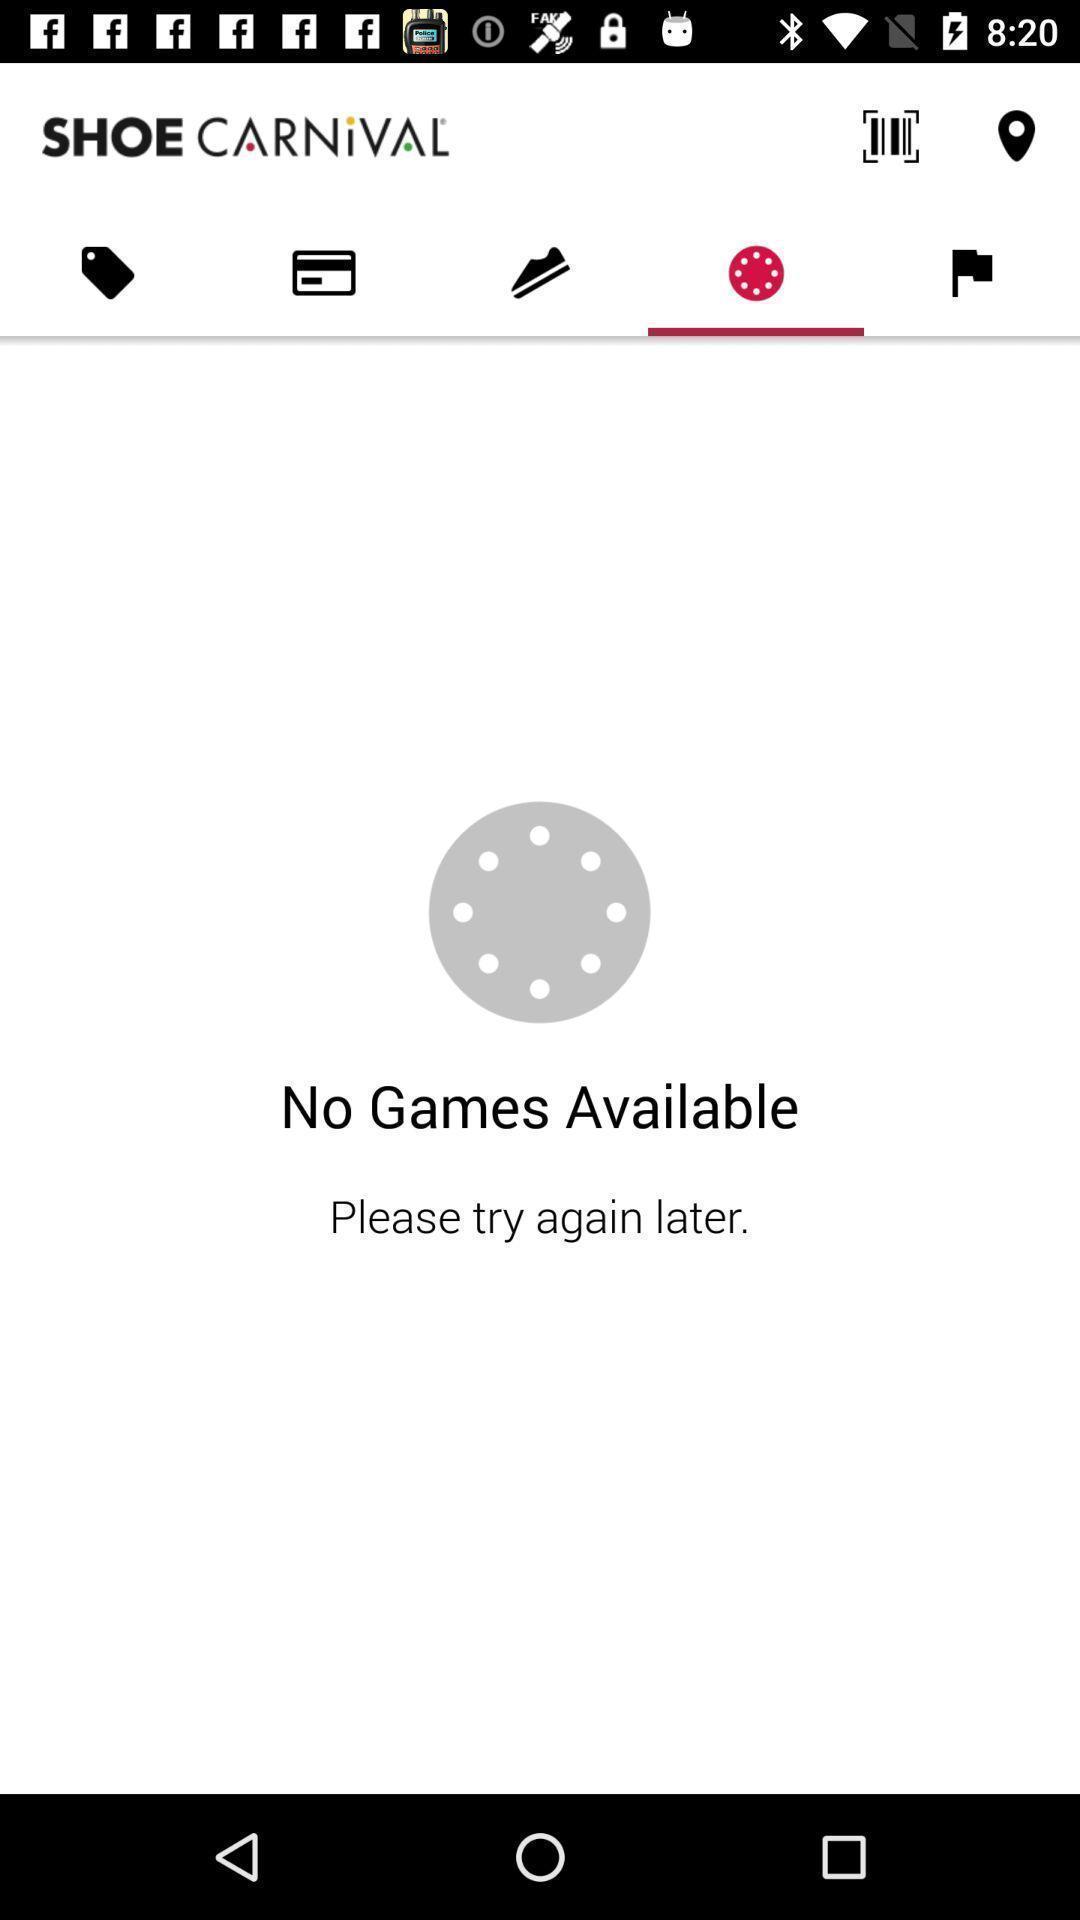Give me a narrative description of this picture. Page shows to find available games in shoes store app. 